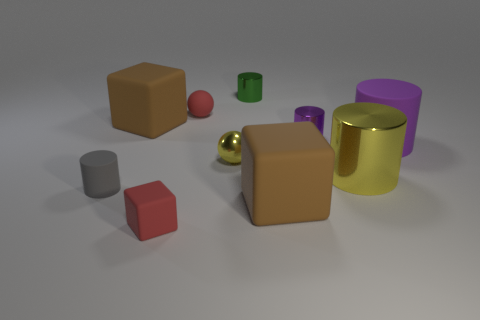There is a large object that is on the left side of the brown block that is to the right of the large block that is behind the yellow shiny ball; what shape is it?
Your response must be concise. Cube. Is the number of small cylinders less than the number of small yellow metallic balls?
Make the answer very short. No. There is a tiny green metallic cylinder; are there any brown things on the left side of it?
Your answer should be compact. Yes. The large object that is both to the right of the tiny green thing and behind the big yellow metal cylinder has what shape?
Give a very brief answer. Cylinder. Are there any small blue things of the same shape as the purple rubber thing?
Give a very brief answer. No. There is a red matte thing that is behind the large yellow shiny cylinder; is its size the same as the red matte thing in front of the tiny gray thing?
Your response must be concise. Yes. Is the number of small gray rubber cylinders greater than the number of blue blocks?
Your answer should be compact. Yes. What number of big purple objects are the same material as the red ball?
Your answer should be very brief. 1. Do the big purple object and the gray thing have the same shape?
Your answer should be compact. Yes. What size is the red matte object right of the red object in front of the tiny yellow sphere to the left of the tiny purple shiny thing?
Ensure brevity in your answer.  Small. 